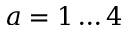<formula> <loc_0><loc_0><loc_500><loc_500>a = 1 \dots 4</formula> 